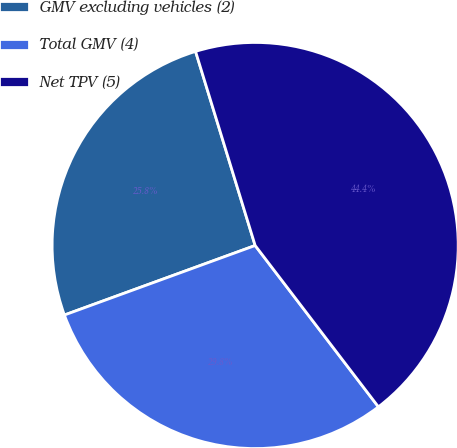Convert chart. <chart><loc_0><loc_0><loc_500><loc_500><pie_chart><fcel>GMV excluding vehicles (2)<fcel>Total GMV (4)<fcel>Net TPV (5)<nl><fcel>25.82%<fcel>29.82%<fcel>44.36%<nl></chart> 